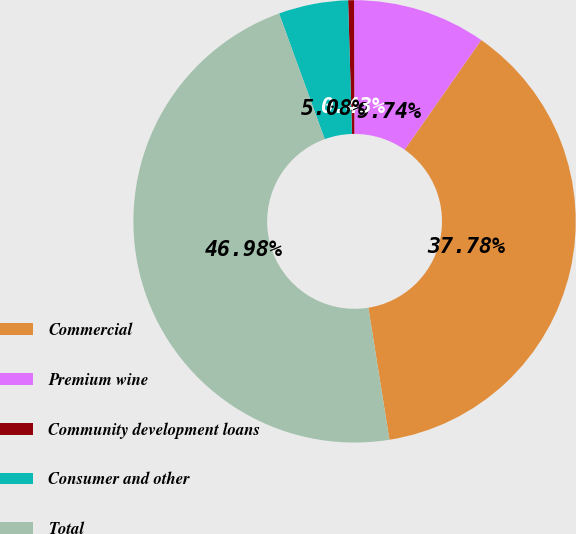<chart> <loc_0><loc_0><loc_500><loc_500><pie_chart><fcel>Commercial<fcel>Premium wine<fcel>Community development loans<fcel>Consumer and other<fcel>Total<nl><fcel>37.78%<fcel>9.74%<fcel>0.43%<fcel>5.08%<fcel>46.98%<nl></chart> 